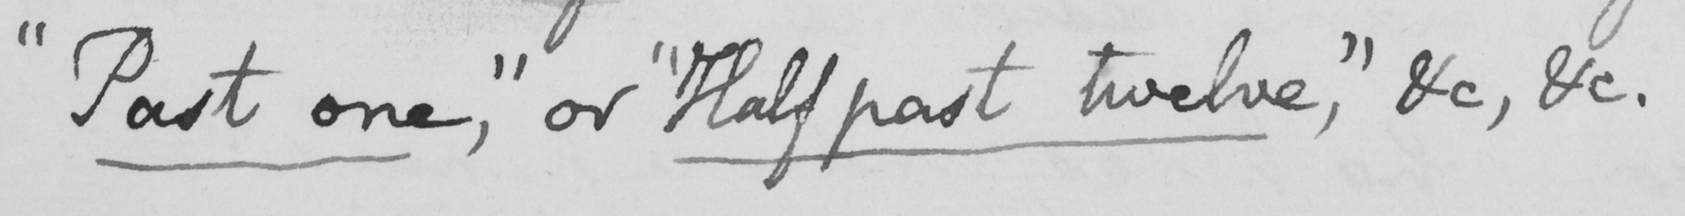What is written in this line of handwriting? " Past one , "  or  " Half past twelve , "  &c , &c . 